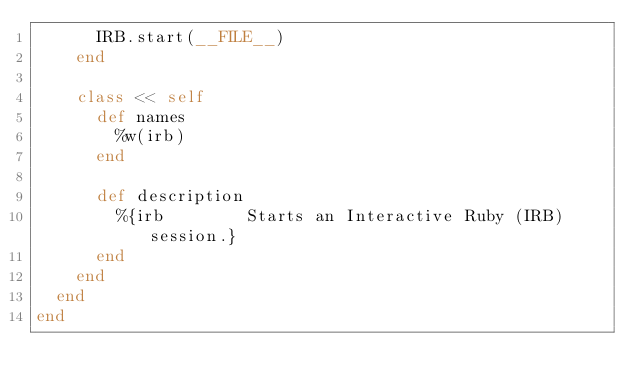<code> <loc_0><loc_0><loc_500><loc_500><_Ruby_>      IRB.start(__FILE__)
    end

    class << self
      def names
        %w(irb)
      end

      def description
        %{irb        Starts an Interactive Ruby (IRB) session.}
      end
    end
  end
end
</code> 